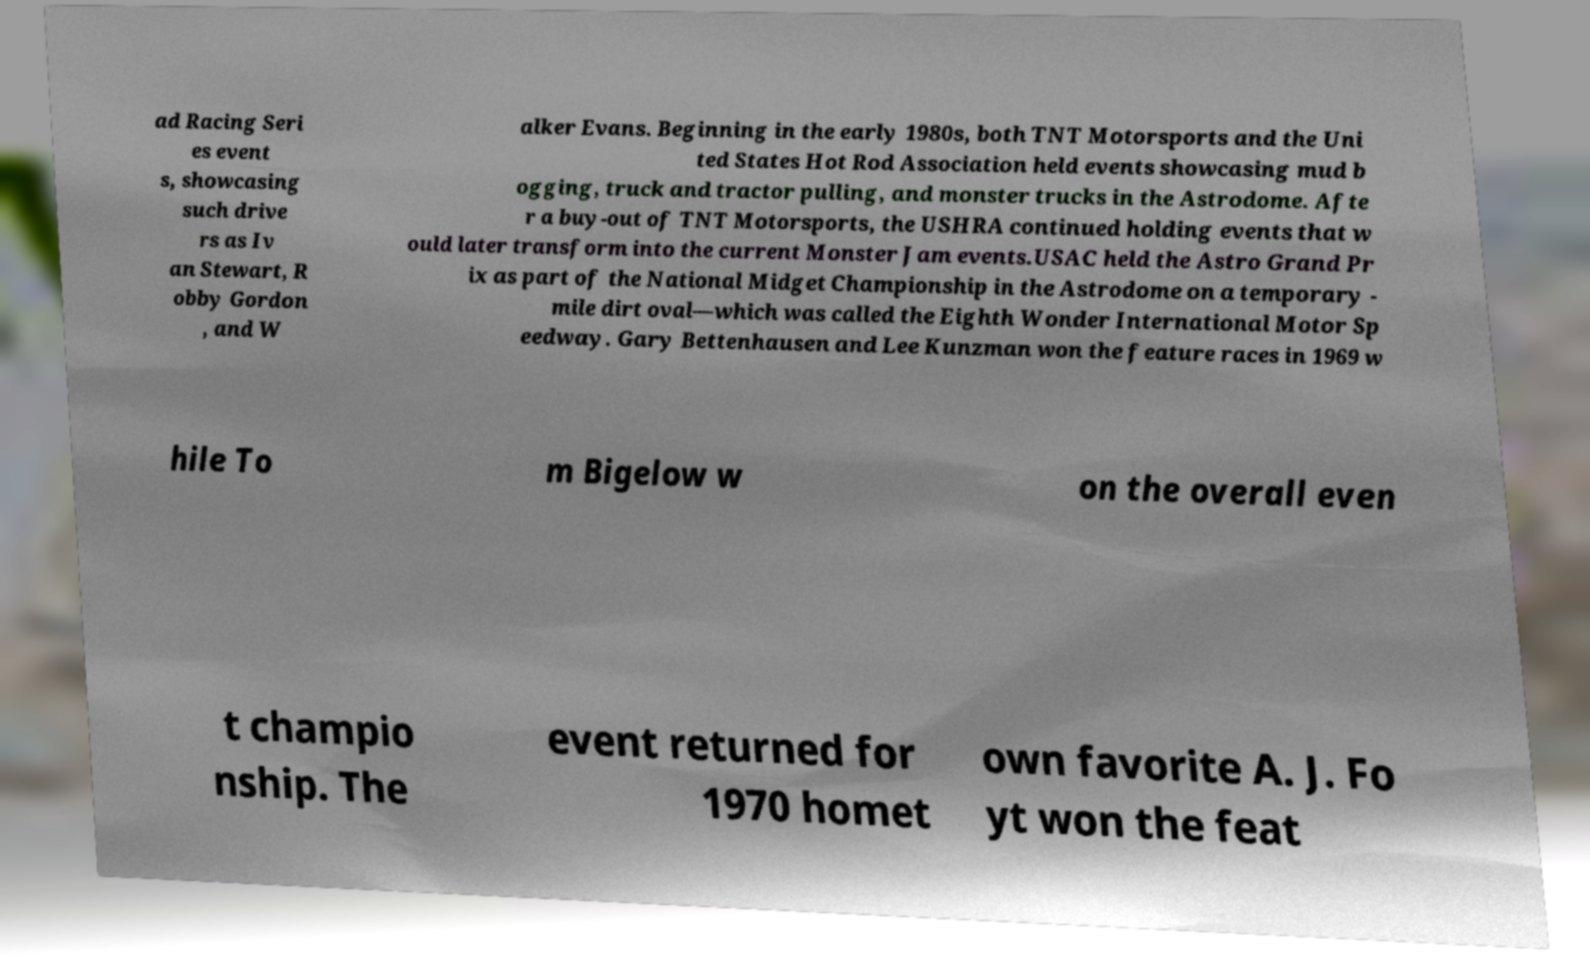Can you accurately transcribe the text from the provided image for me? ad Racing Seri es event s, showcasing such drive rs as Iv an Stewart, R obby Gordon , and W alker Evans. Beginning in the early 1980s, both TNT Motorsports and the Uni ted States Hot Rod Association held events showcasing mud b ogging, truck and tractor pulling, and monster trucks in the Astrodome. Afte r a buy-out of TNT Motorsports, the USHRA continued holding events that w ould later transform into the current Monster Jam events.USAC held the Astro Grand Pr ix as part of the National Midget Championship in the Astrodome on a temporary - mile dirt oval—which was called the Eighth Wonder International Motor Sp eedway. Gary Bettenhausen and Lee Kunzman won the feature races in 1969 w hile To m Bigelow w on the overall even t champio nship. The event returned for 1970 homet own favorite A. J. Fo yt won the feat 